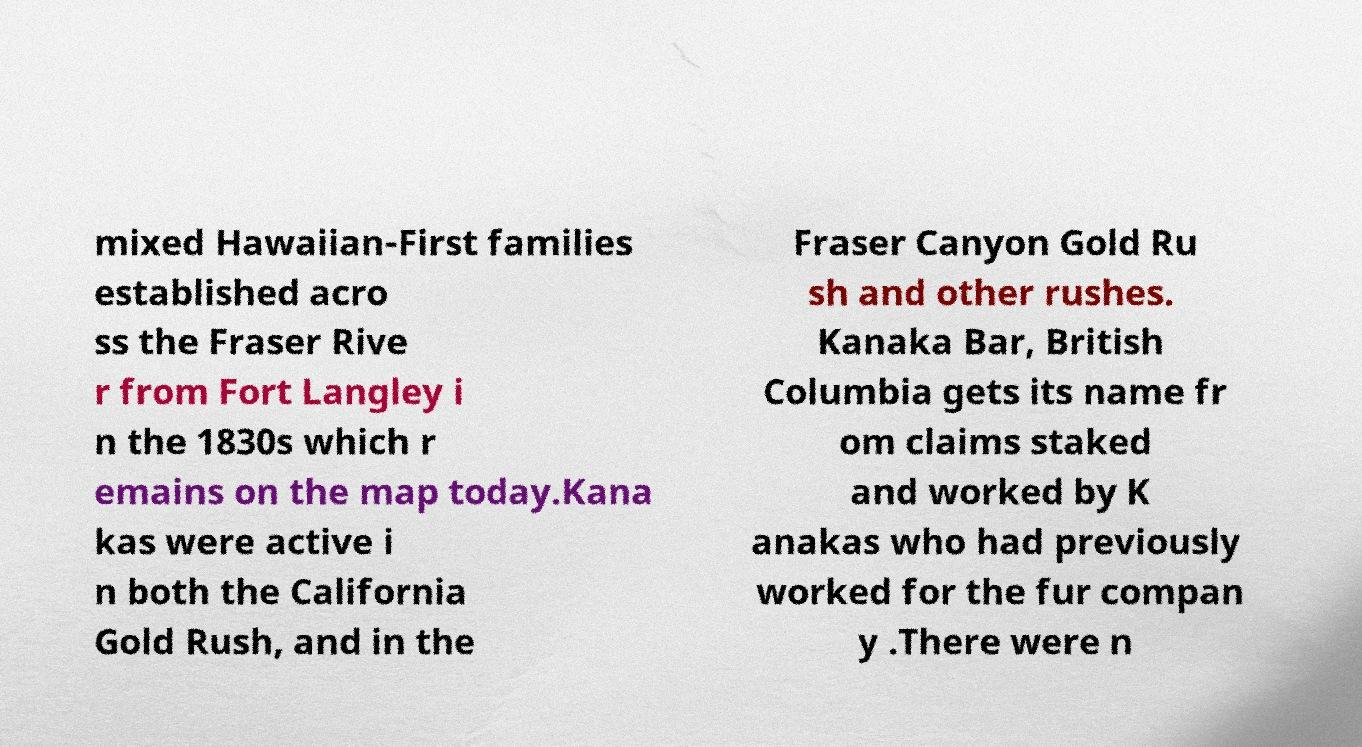I need the written content from this picture converted into text. Can you do that? mixed Hawaiian-First families established acro ss the Fraser Rive r from Fort Langley i n the 1830s which r emains on the map today.Kana kas were active i n both the California Gold Rush, and in the Fraser Canyon Gold Ru sh and other rushes. Kanaka Bar, British Columbia gets its name fr om claims staked and worked by K anakas who had previously worked for the fur compan y .There were n 